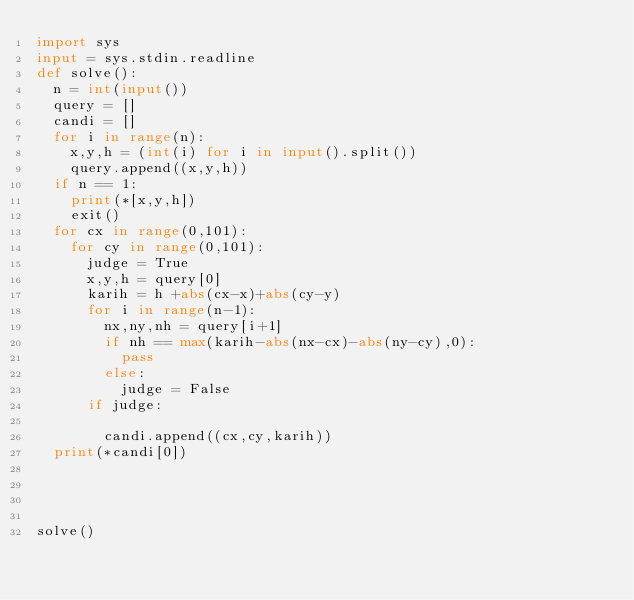<code> <loc_0><loc_0><loc_500><loc_500><_Python_>import sys
input = sys.stdin.readline
def solve():
  n = int(input())
  query = []
  candi = []
  for i in range(n):
    x,y,h = (int(i) for i in input().split())
    query.append((x,y,h))
  if n == 1:
    print(*[x,y,h])
    exit()
  for cx in range(0,101):
    for cy in range(0,101):
      judge = True
      x,y,h = query[0]
      karih = h +abs(cx-x)+abs(cy-y)
      for i in range(n-1):
        nx,ny,nh = query[i+1]
        if nh == max(karih-abs(nx-cx)-abs(ny-cy),0):
          pass
        else:
          judge = False
      if judge:

        candi.append((cx,cy,karih))
  print(*candi[0])
        
          
      
      
solve()</code> 